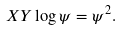Convert formula to latex. <formula><loc_0><loc_0><loc_500><loc_500>X Y \log \psi = \psi ^ { 2 } .</formula> 